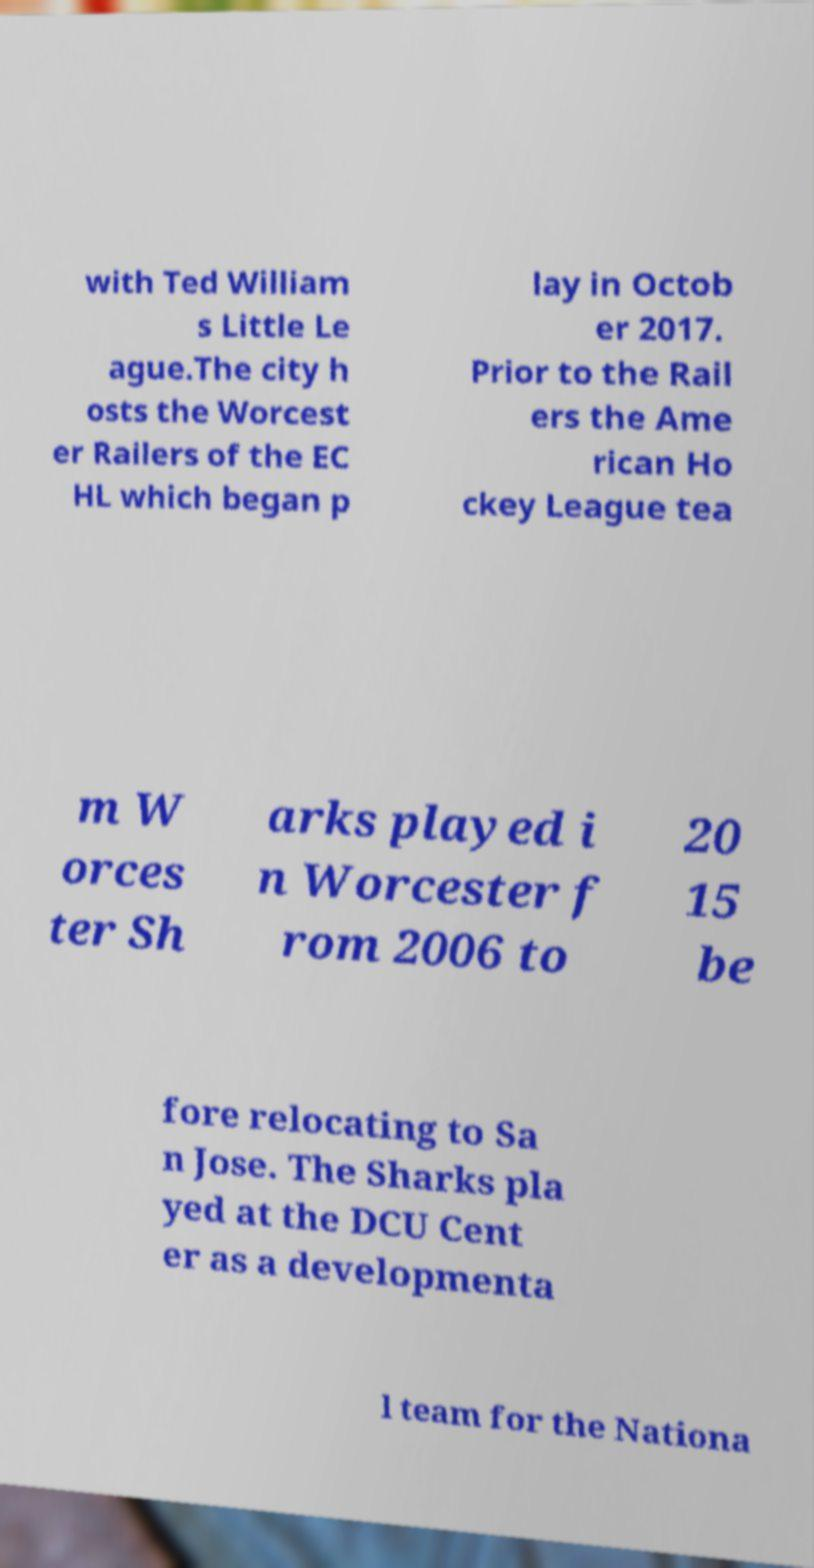Could you assist in decoding the text presented in this image and type it out clearly? with Ted William s Little Le ague.The city h osts the Worcest er Railers of the EC HL which began p lay in Octob er 2017. Prior to the Rail ers the Ame rican Ho ckey League tea m W orces ter Sh arks played i n Worcester f rom 2006 to 20 15 be fore relocating to Sa n Jose. The Sharks pla yed at the DCU Cent er as a developmenta l team for the Nationa 